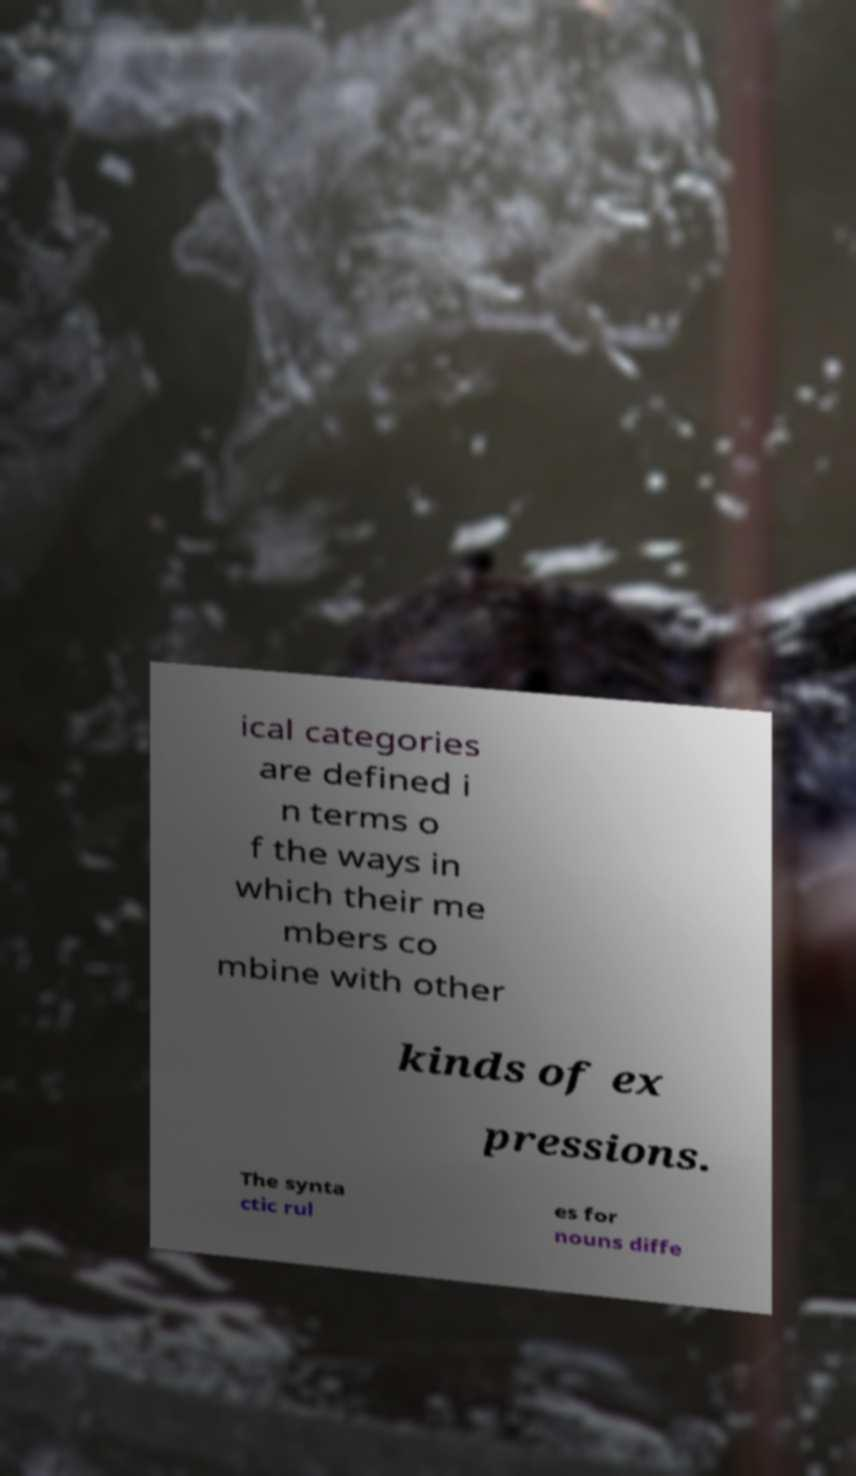Please identify and transcribe the text found in this image. ical categories are defined i n terms o f the ways in which their me mbers co mbine with other kinds of ex pressions. The synta ctic rul es for nouns diffe 